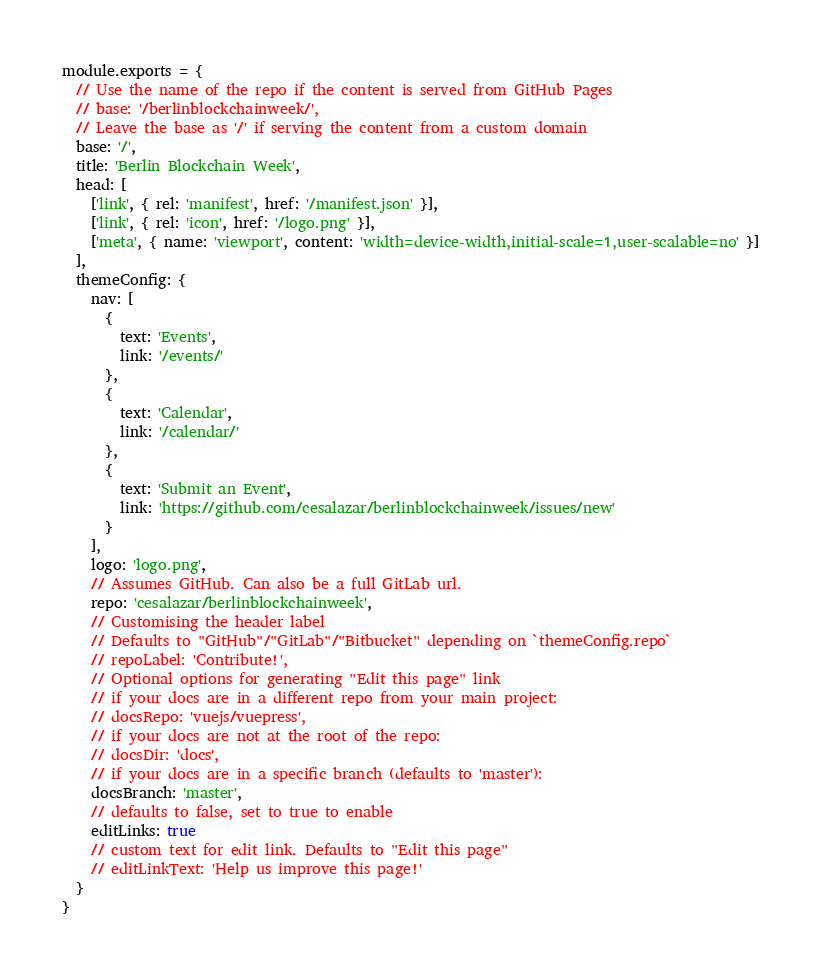Convert code to text. <code><loc_0><loc_0><loc_500><loc_500><_JavaScript_>module.exports = {
  // Use the name of the repo if the content is served from GitHub Pages
  // base: '/berlinblockchainweek/',
  // Leave the base as '/' if serving the content from a custom domain
  base: '/',
  title: 'Berlin Blockchain Week',
  head: [
    ['link', { rel: 'manifest', href: '/manifest.json' }],
    ['link', { rel: 'icon', href: '/logo.png' }],
    ['meta', { name: 'viewport', content: 'width=device-width,initial-scale=1,user-scalable=no' }]
  ],
  themeConfig: {
    nav: [
      {
        text: 'Events',
        link: '/events/'
      },
      {
        text: 'Calendar',
        link: '/calendar/'
      },
      {
        text: 'Submit an Event',
        link: 'https://github.com/cesalazar/berlinblockchainweek/issues/new'
      }
    ],
    logo: 'logo.png',
    // Assumes GitHub. Can also be a full GitLab url.
    repo: 'cesalazar/berlinblockchainweek',
    // Customising the header label
    // Defaults to "GitHub"/"GitLab"/"Bitbucket" depending on `themeConfig.repo`
    // repoLabel: 'Contribute!',
    // Optional options for generating "Edit this page" link
    // if your docs are in a different repo from your main project:
    // docsRepo: 'vuejs/vuepress',
    // if your docs are not at the root of the repo:
    // docsDir: 'docs',
    // if your docs are in a specific branch (defaults to 'master'):
    docsBranch: 'master',
    // defaults to false, set to true to enable
    editLinks: true
    // custom text for edit link. Defaults to "Edit this page"
    // editLinkText: 'Help us improve this page!'
  }
}
</code> 